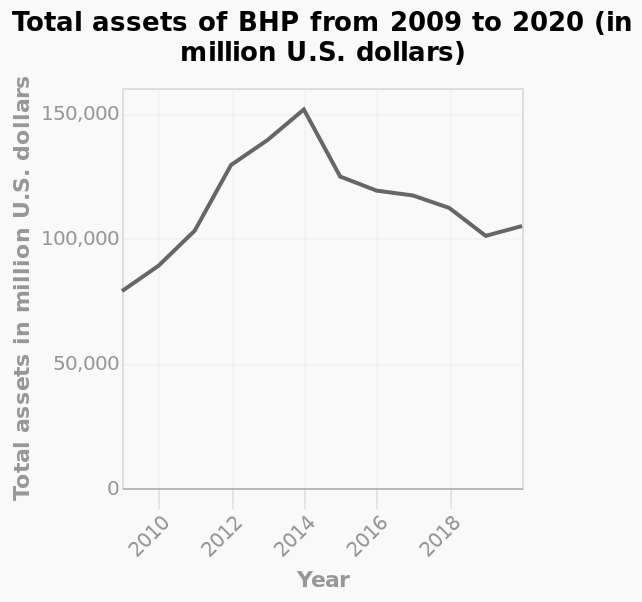<image>
How did the total assets change from 2009 to 2019? The total assets initially increased from 2009 to 2014 but then declined sharply from 2014 to 2015, followed by a steady decline to 2019. please summary the statistics and relations of the chart The total assets had an upward trend from 2009 t9 2014 but then fell sharply from 2014 to 2015. From there they continued to fall steadily to 2019. In which year did the total assets experience a sharp decline?  The total assets fell sharply from 2014 to 2015. Did the total assets rise sharply from 2014 to 2015? No. The total assets fell sharply from 2014 to 2015. 